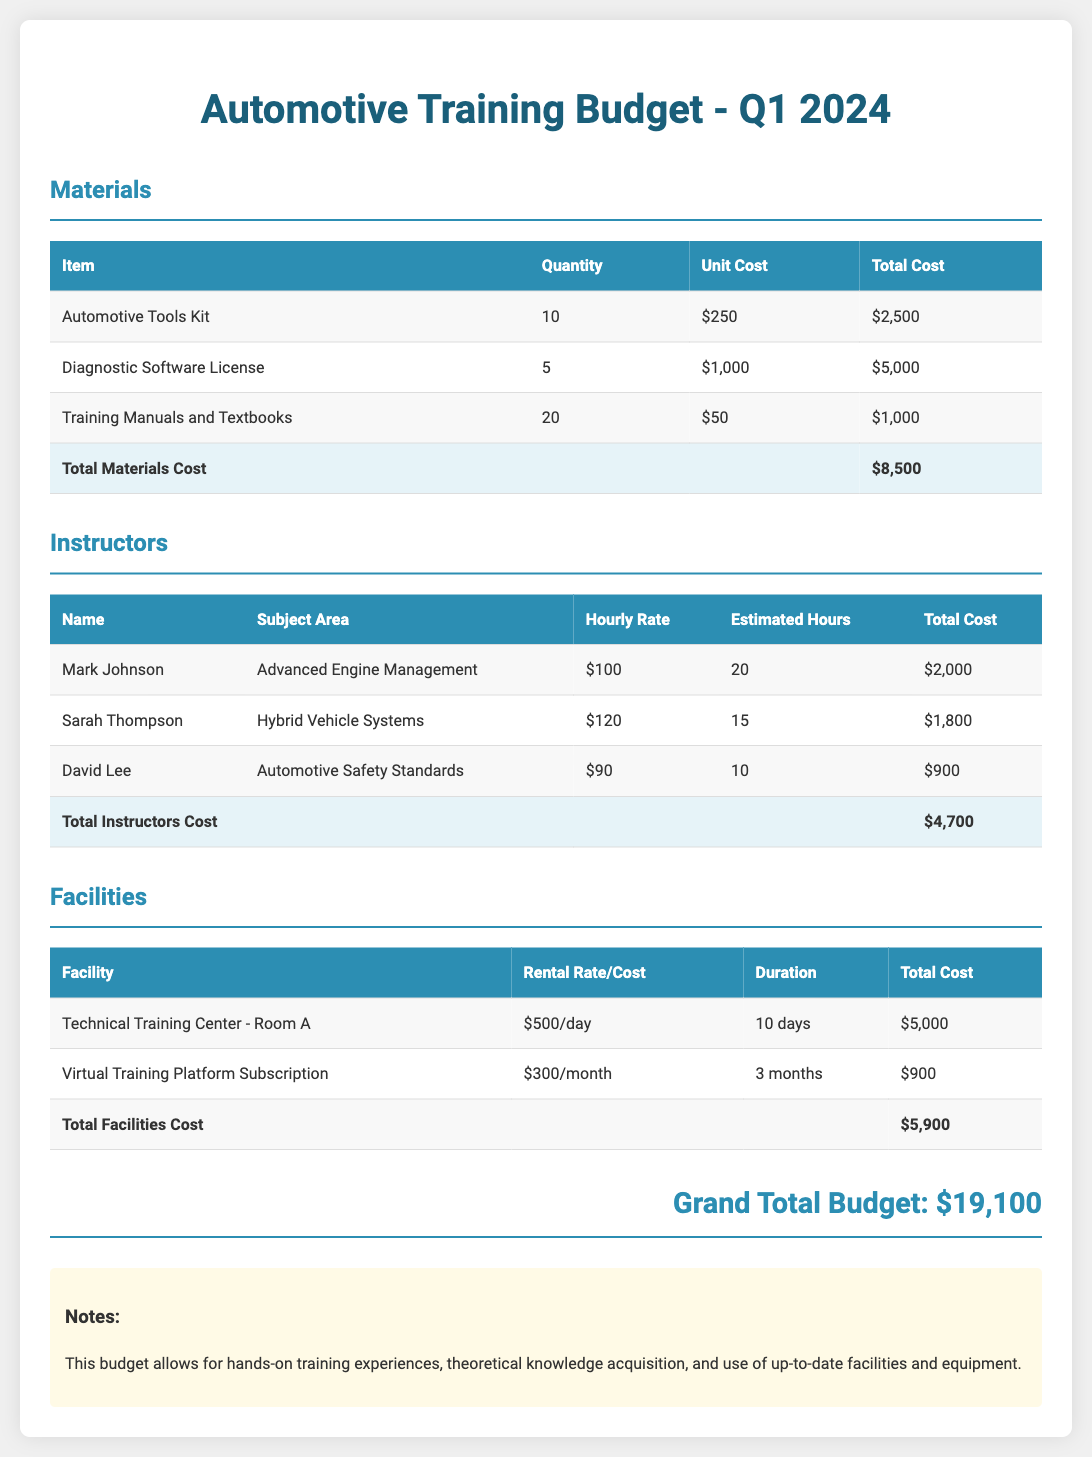What is the total cost for materials? The total cost for materials is listed in the "Total Materials Cost" row of the materials table, which is $8,500.
Answer: $8,500 How many instructors are listed in the budget? The number of instructors can be counted from the instructors table, which has three listed: Mark Johnson, Sarah Thompson, and David Lee.
Answer: 3 What is the hourly rate for Sarah Thompson? Sarah Thompson's hourly rate is found in the instructors table, which is $120.
Answer: $120 What is the total cost for facilities? The total cost for facilities is provided in the "Total Facilities Cost" row of the facilities table, which is $5,900.
Answer: $5,900 What is the name of the facility with the highest rental rate? The facility with the highest rental rate is identified in the facilities table: "Technical Training Center - Room A" at $500 per day.
Answer: Technical Training Center - Room A What is the total budget for the quarter? The grand total budget is noted at the bottom of the document, which sums up all categories, resulting in $19,100.
Answer: $19,100 How much does the "Diagnostic Software License" cost? The cost for the "Diagnostic Software License" is found in the materials table, which shows a total cost of $5,000.
Answer: $5,000 How many days is the facility "Technical Training Center - Room A" rented for? The duration of the rent for "Technical Training Center - Room A" is stated in the facilities table as 10 days.
Answer: 10 days What is the total estimated instructor cost? The total estimated instructor cost is presented in the budget as $4,700 in the total instructors cost row.
Answer: $4,700 